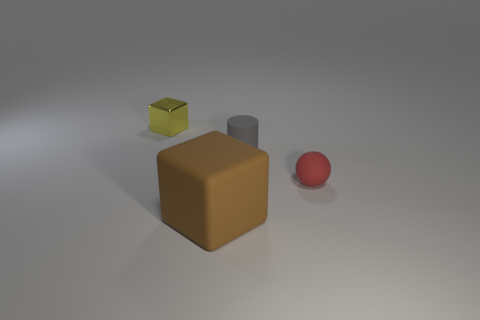Add 4 tiny red rubber cylinders. How many objects exist? 8 Subtract 1 cylinders. How many cylinders are left? 0 Add 4 small balls. How many small balls are left? 5 Add 3 red spheres. How many red spheres exist? 4 Subtract 0 yellow spheres. How many objects are left? 4 Subtract all cylinders. How many objects are left? 3 Subtract all blue spheres. Subtract all green blocks. How many spheres are left? 1 Subtract all red objects. Subtract all tiny gray matte cylinders. How many objects are left? 2 